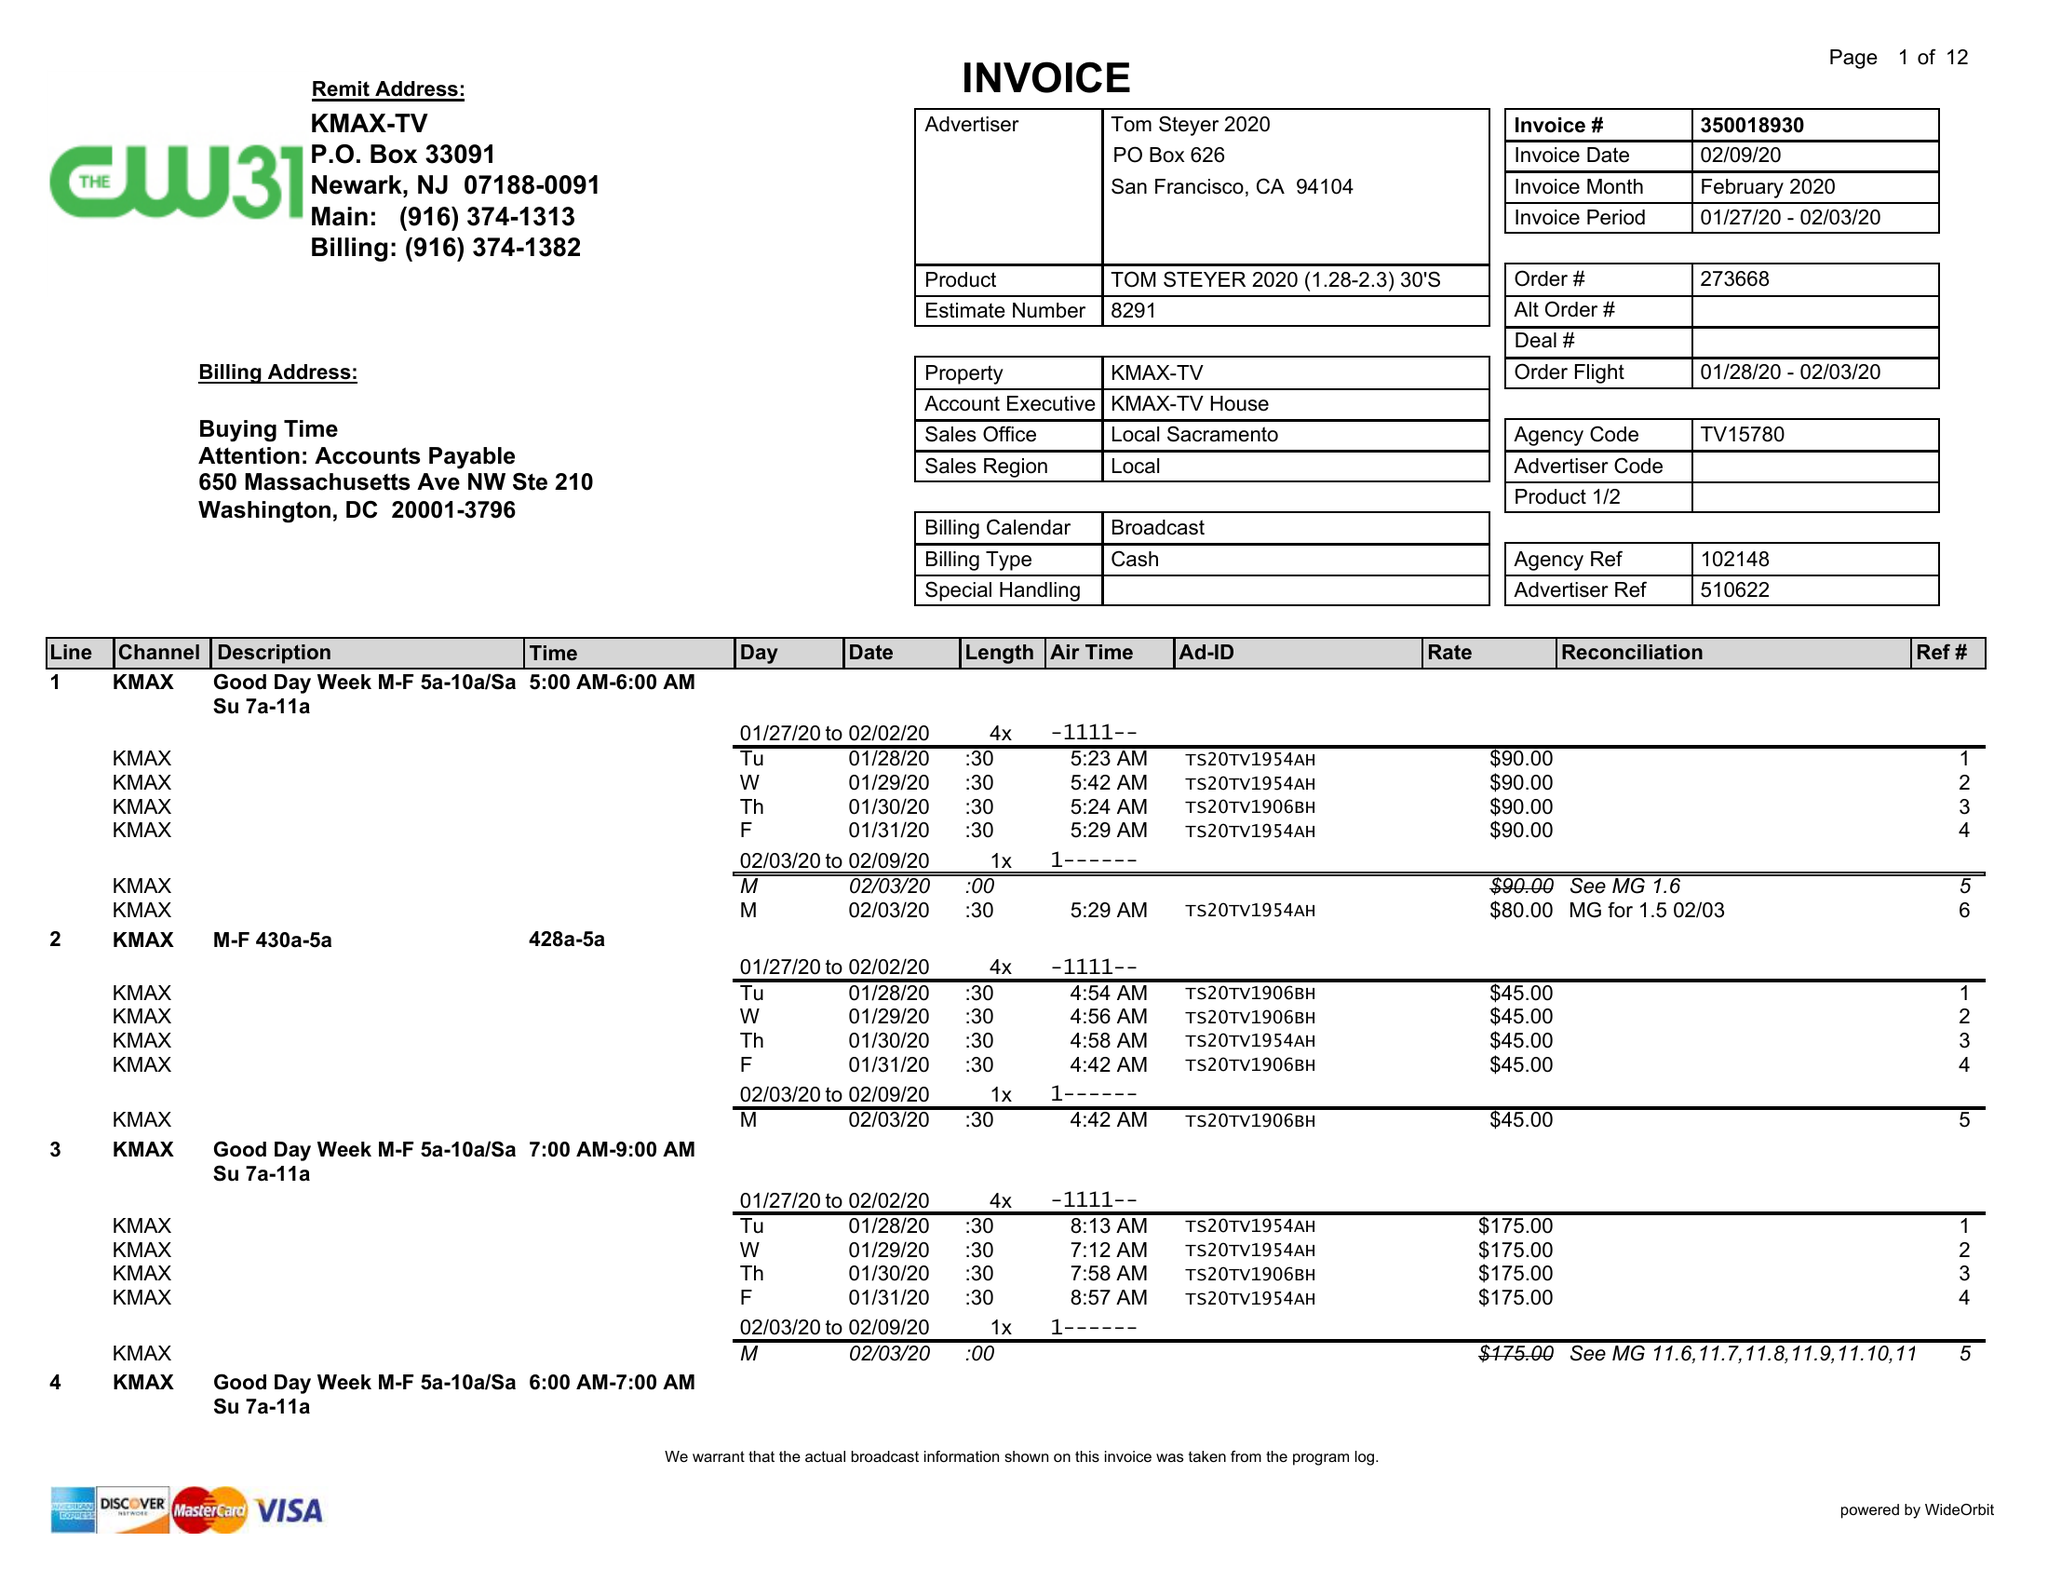What is the value for the flight_from?
Answer the question using a single word or phrase. 01/28/20 